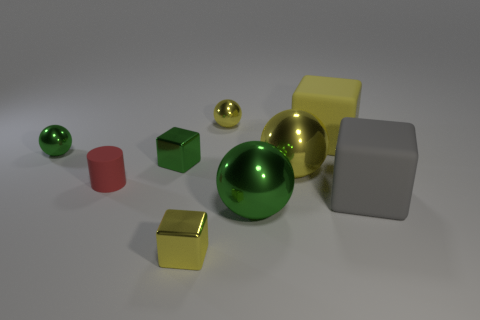Do the cylinder and the small block behind the cylinder have the same color?
Your response must be concise. No. How many yellow things are tiny cylinders or small things?
Provide a short and direct response. 2. Are there the same number of big yellow metallic objects left of the big green object and big green shiny cubes?
Your response must be concise. Yes. Are there any other things that have the same size as the gray object?
Give a very brief answer. Yes. The other large object that is the same shape as the large yellow matte thing is what color?
Offer a very short reply. Gray. How many small yellow objects have the same shape as the tiny red object?
Offer a very short reply. 0. How many green cubes are there?
Offer a terse response. 1. Is there a yellow ball made of the same material as the small red cylinder?
Ensure brevity in your answer.  No. Do the green metal object on the left side of the green shiny block and the green metallic sphere in front of the red matte object have the same size?
Offer a terse response. No. What size is the green sphere that is behind the big green metallic sphere?
Your answer should be very brief. Small. 